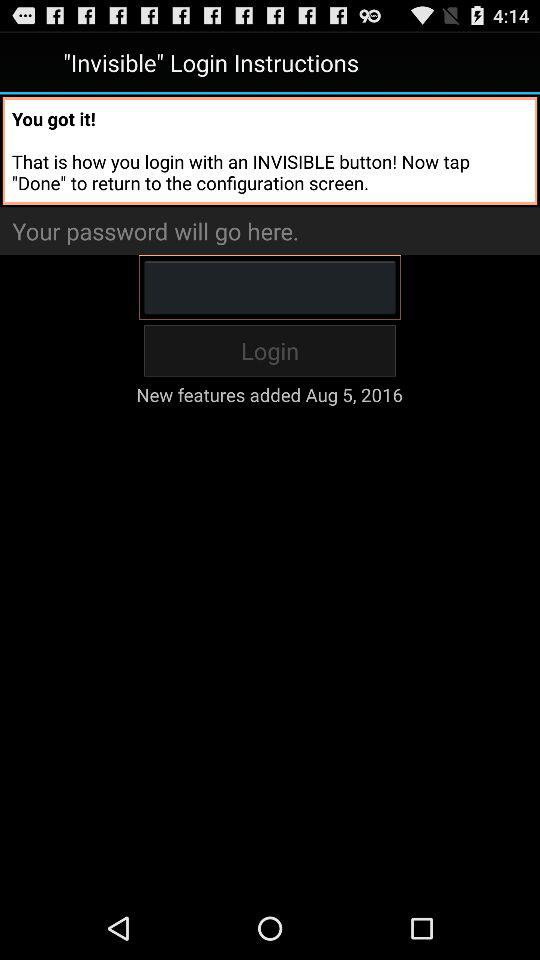What to do to return to the configuration screen? To return to the configuration screen, tap "Done". 